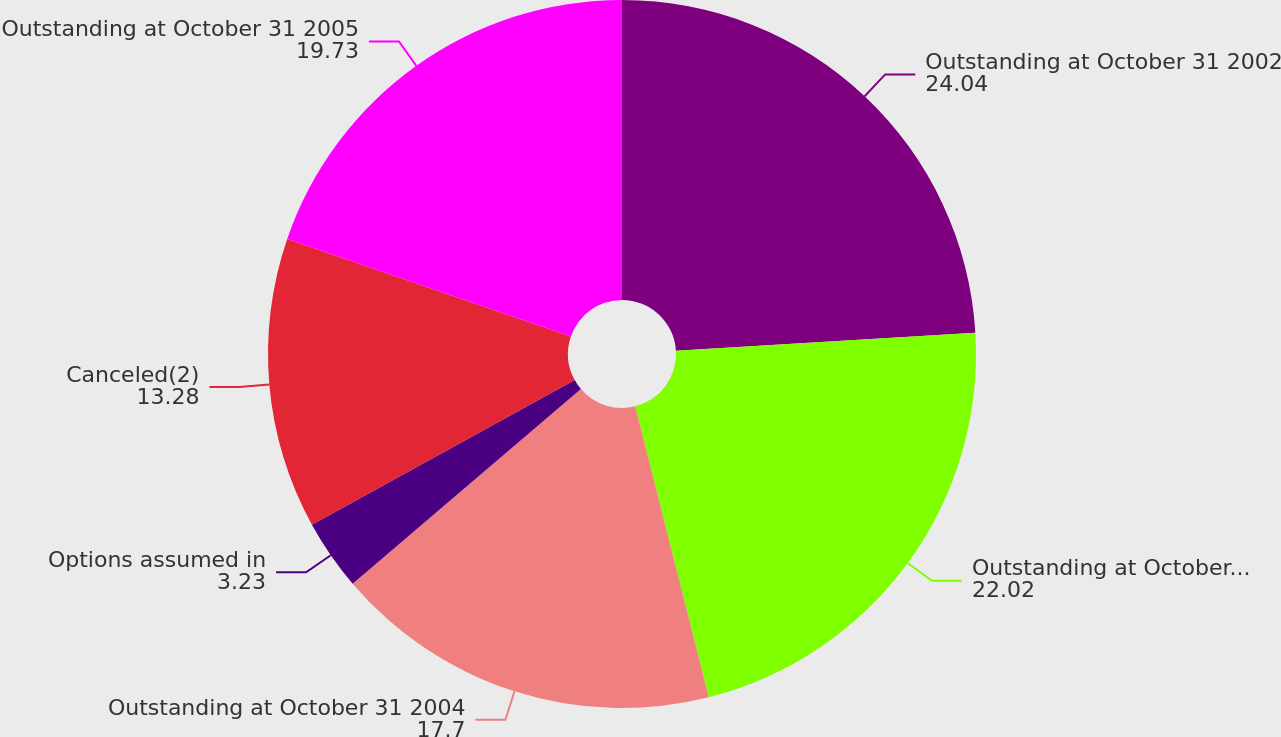Convert chart. <chart><loc_0><loc_0><loc_500><loc_500><pie_chart><fcel>Outstanding at October 31 2002<fcel>Outstanding at October 31 2003<fcel>Outstanding at October 31 2004<fcel>Options assumed in<fcel>Canceled(2)<fcel>Outstanding at October 31 2005<nl><fcel>24.04%<fcel>22.02%<fcel>17.7%<fcel>3.23%<fcel>13.28%<fcel>19.73%<nl></chart> 